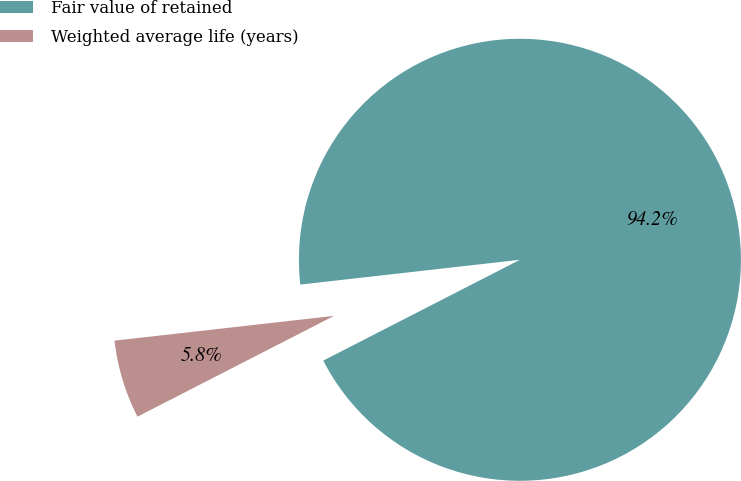Convert chart to OTSL. <chart><loc_0><loc_0><loc_500><loc_500><pie_chart><fcel>Fair value of retained<fcel>Weighted average life (years)<nl><fcel>94.25%<fcel>5.75%<nl></chart> 